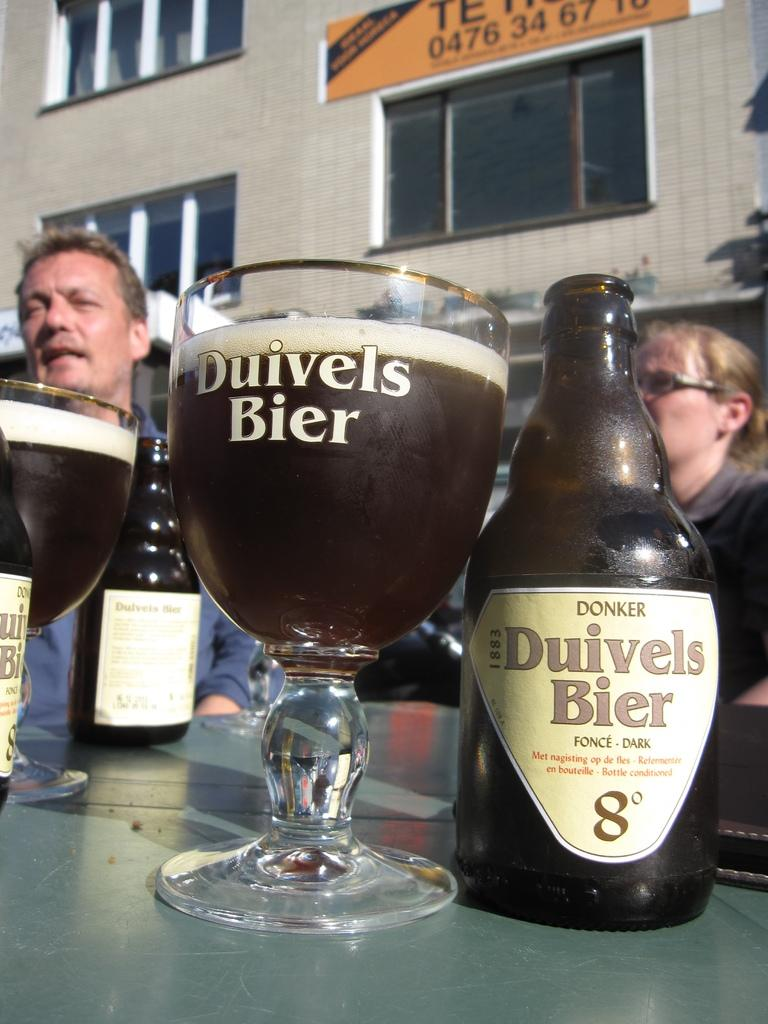Provide a one-sentence caption for the provided image. Two people sitting behind a glass of Duivels Bier. 